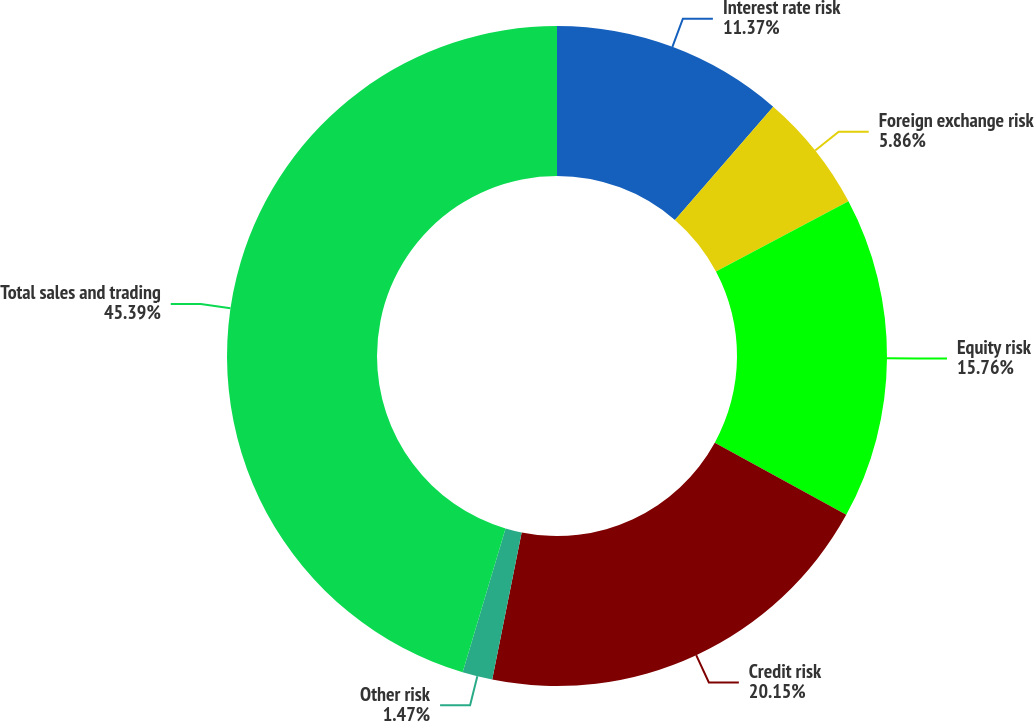<chart> <loc_0><loc_0><loc_500><loc_500><pie_chart><fcel>Interest rate risk<fcel>Foreign exchange risk<fcel>Equity risk<fcel>Credit risk<fcel>Other risk<fcel>Total sales and trading<nl><fcel>11.37%<fcel>5.86%<fcel>15.76%<fcel>20.15%<fcel>1.47%<fcel>45.38%<nl></chart> 